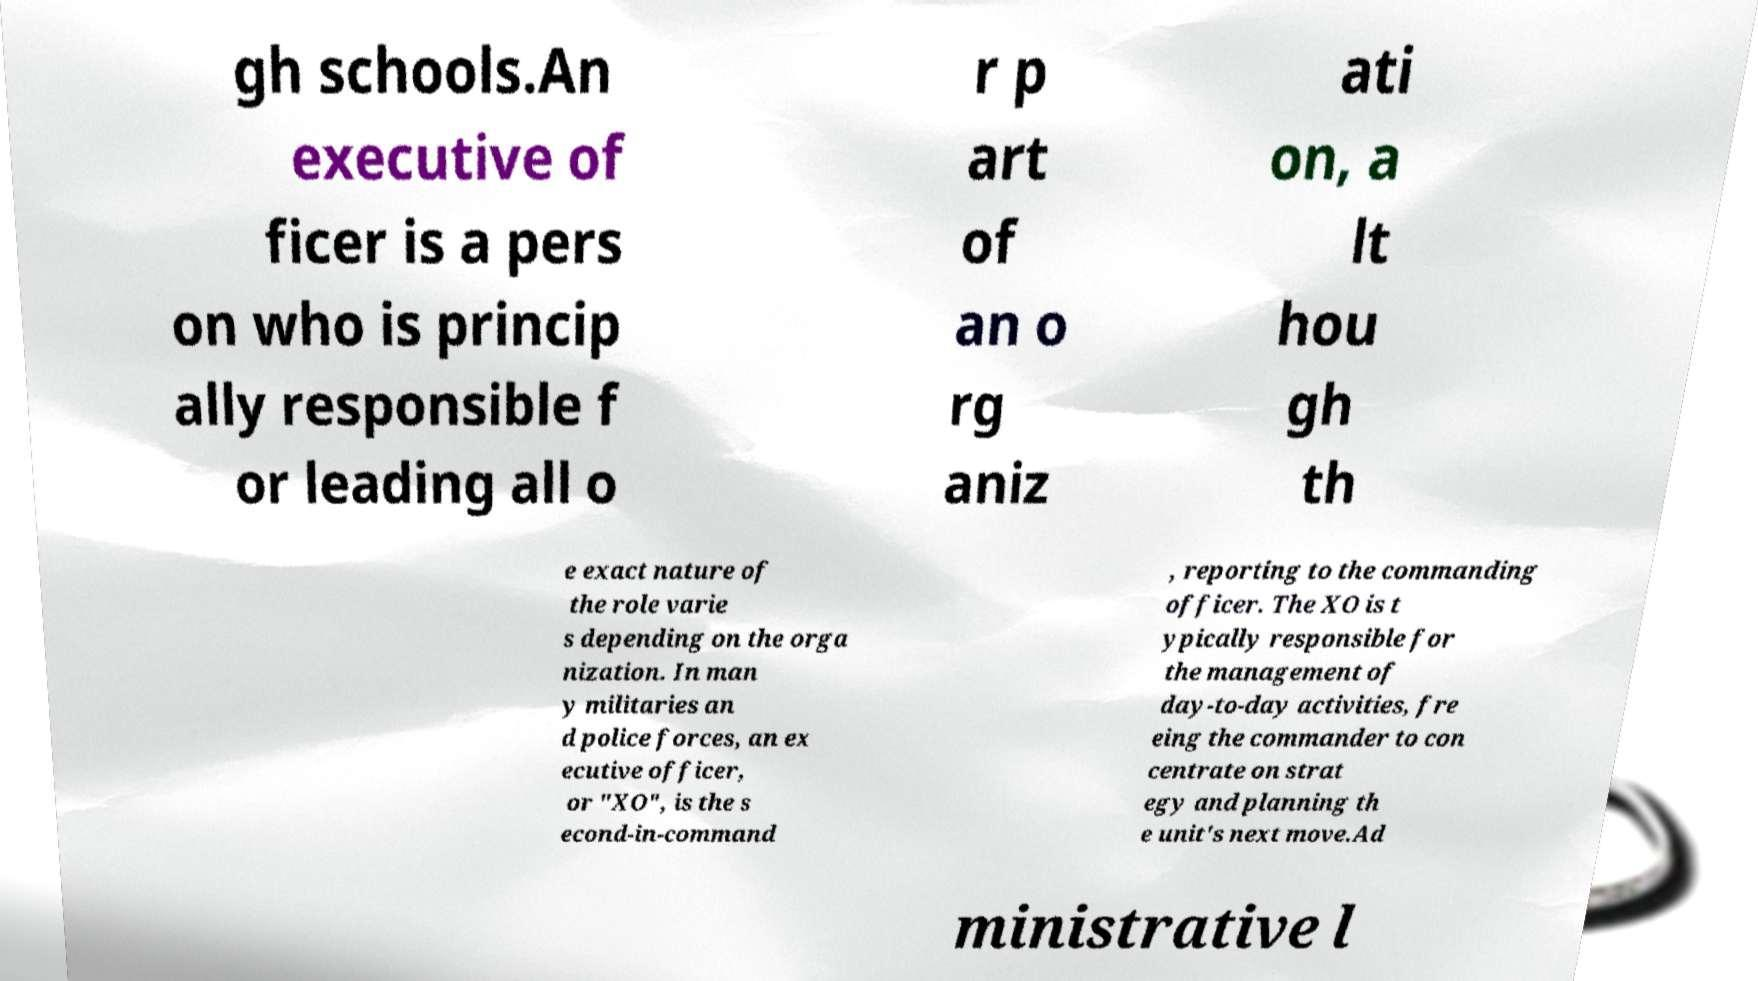I need the written content from this picture converted into text. Can you do that? gh schools.An executive of ficer is a pers on who is princip ally responsible f or leading all o r p art of an o rg aniz ati on, a lt hou gh th e exact nature of the role varie s depending on the orga nization. In man y militaries an d police forces, an ex ecutive officer, or "XO", is the s econd-in-command , reporting to the commanding officer. The XO is t ypically responsible for the management of day-to-day activities, fre eing the commander to con centrate on strat egy and planning th e unit's next move.Ad ministrative l 